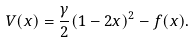<formula> <loc_0><loc_0><loc_500><loc_500>V ( x ) = \frac { \gamma } { 2 } ( 1 - 2 x ) ^ { 2 } - f ( x ) .</formula> 